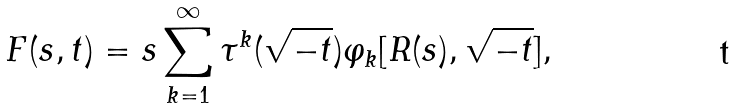<formula> <loc_0><loc_0><loc_500><loc_500>F ( s , t ) = s \sum _ { k = 1 } ^ { \infty } \tau ^ { k } ( \sqrt { - t } ) \varphi _ { k } [ R ( s ) , \sqrt { - t } ] ,</formula> 